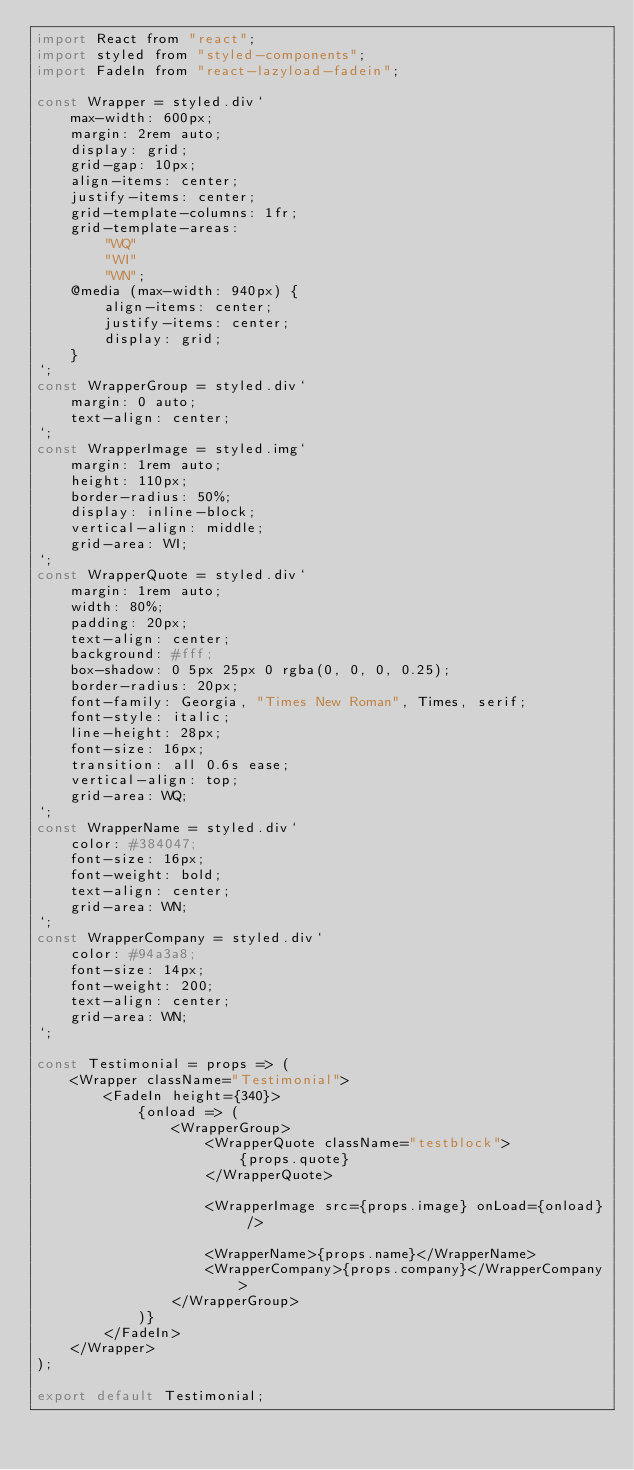<code> <loc_0><loc_0><loc_500><loc_500><_JavaScript_>import React from "react";
import styled from "styled-components";
import FadeIn from "react-lazyload-fadein";

const Wrapper = styled.div`
    max-width: 600px;
    margin: 2rem auto;
    display: grid;
    grid-gap: 10px;
    align-items: center;
    justify-items: center;
    grid-template-columns: 1fr;
    grid-template-areas:
        "WQ"
        "WI"
        "WN";
    @media (max-width: 940px) {
        align-items: center;
        justify-items: center;
        display: grid;
    }
`;
const WrapperGroup = styled.div`
    margin: 0 auto;
    text-align: center;
`;
const WrapperImage = styled.img`
    margin: 1rem auto;
    height: 110px;
    border-radius: 50%;
    display: inline-block;
    vertical-align: middle;
    grid-area: WI;
`;
const WrapperQuote = styled.div`
    margin: 1rem auto;
    width: 80%;
    padding: 20px;
    text-align: center;
    background: #fff;
    box-shadow: 0 5px 25px 0 rgba(0, 0, 0, 0.25);
    border-radius: 20px;
    font-family: Georgia, "Times New Roman", Times, serif;
    font-style: italic;
    line-height: 28px;
    font-size: 16px;
    transition: all 0.6s ease;
    vertical-align: top;
    grid-area: WQ;
`;
const WrapperName = styled.div`
    color: #384047;
    font-size: 16px;
    font-weight: bold;
    text-align: center;
    grid-area: WN;
`;
const WrapperCompany = styled.div`
    color: #94a3a8;
    font-size: 14px;
    font-weight: 200;
    text-align: center;
    grid-area: WN;
`;

const Testimonial = props => (
    <Wrapper className="Testimonial">
        <FadeIn height={340}>
            {onload => (
                <WrapperGroup>
                    <WrapperQuote className="testblock">
                        {props.quote}
                    </WrapperQuote>

                    <WrapperImage src={props.image} onLoad={onload} />

                    <WrapperName>{props.name}</WrapperName>
                    <WrapperCompany>{props.company}</WrapperCompany>
                </WrapperGroup>
            )}
        </FadeIn>
    </Wrapper>
);

export default Testimonial;
</code> 